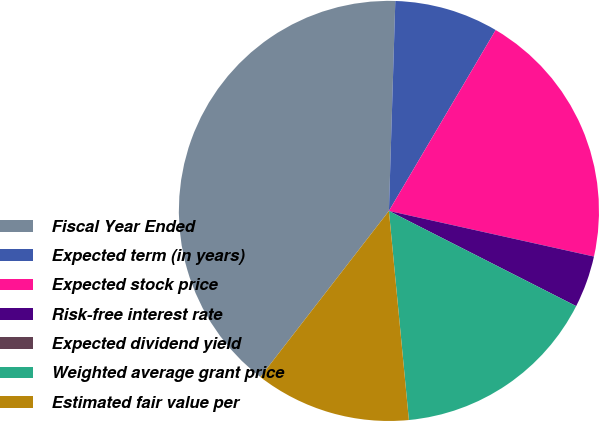Convert chart to OTSL. <chart><loc_0><loc_0><loc_500><loc_500><pie_chart><fcel>Fiscal Year Ended<fcel>Expected term (in years)<fcel>Expected stock price<fcel>Risk-free interest rate<fcel>Expected dividend yield<fcel>Weighted average grant price<fcel>Estimated fair value per<nl><fcel>40.0%<fcel>8.0%<fcel>20.0%<fcel>4.0%<fcel>0.0%<fcel>16.0%<fcel>12.0%<nl></chart> 